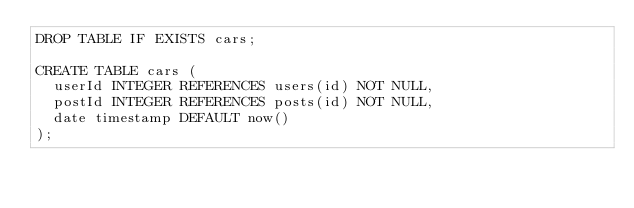Convert code to text. <code><loc_0><loc_0><loc_500><loc_500><_SQL_>DROP TABLE IF EXISTS cars;

CREATE TABLE cars (
  userId INTEGER REFERENCES users(id) NOT NULL,
  postId INTEGER REFERENCES posts(id) NOT NULL,
  date timestamp DEFAULT now()
);
</code> 